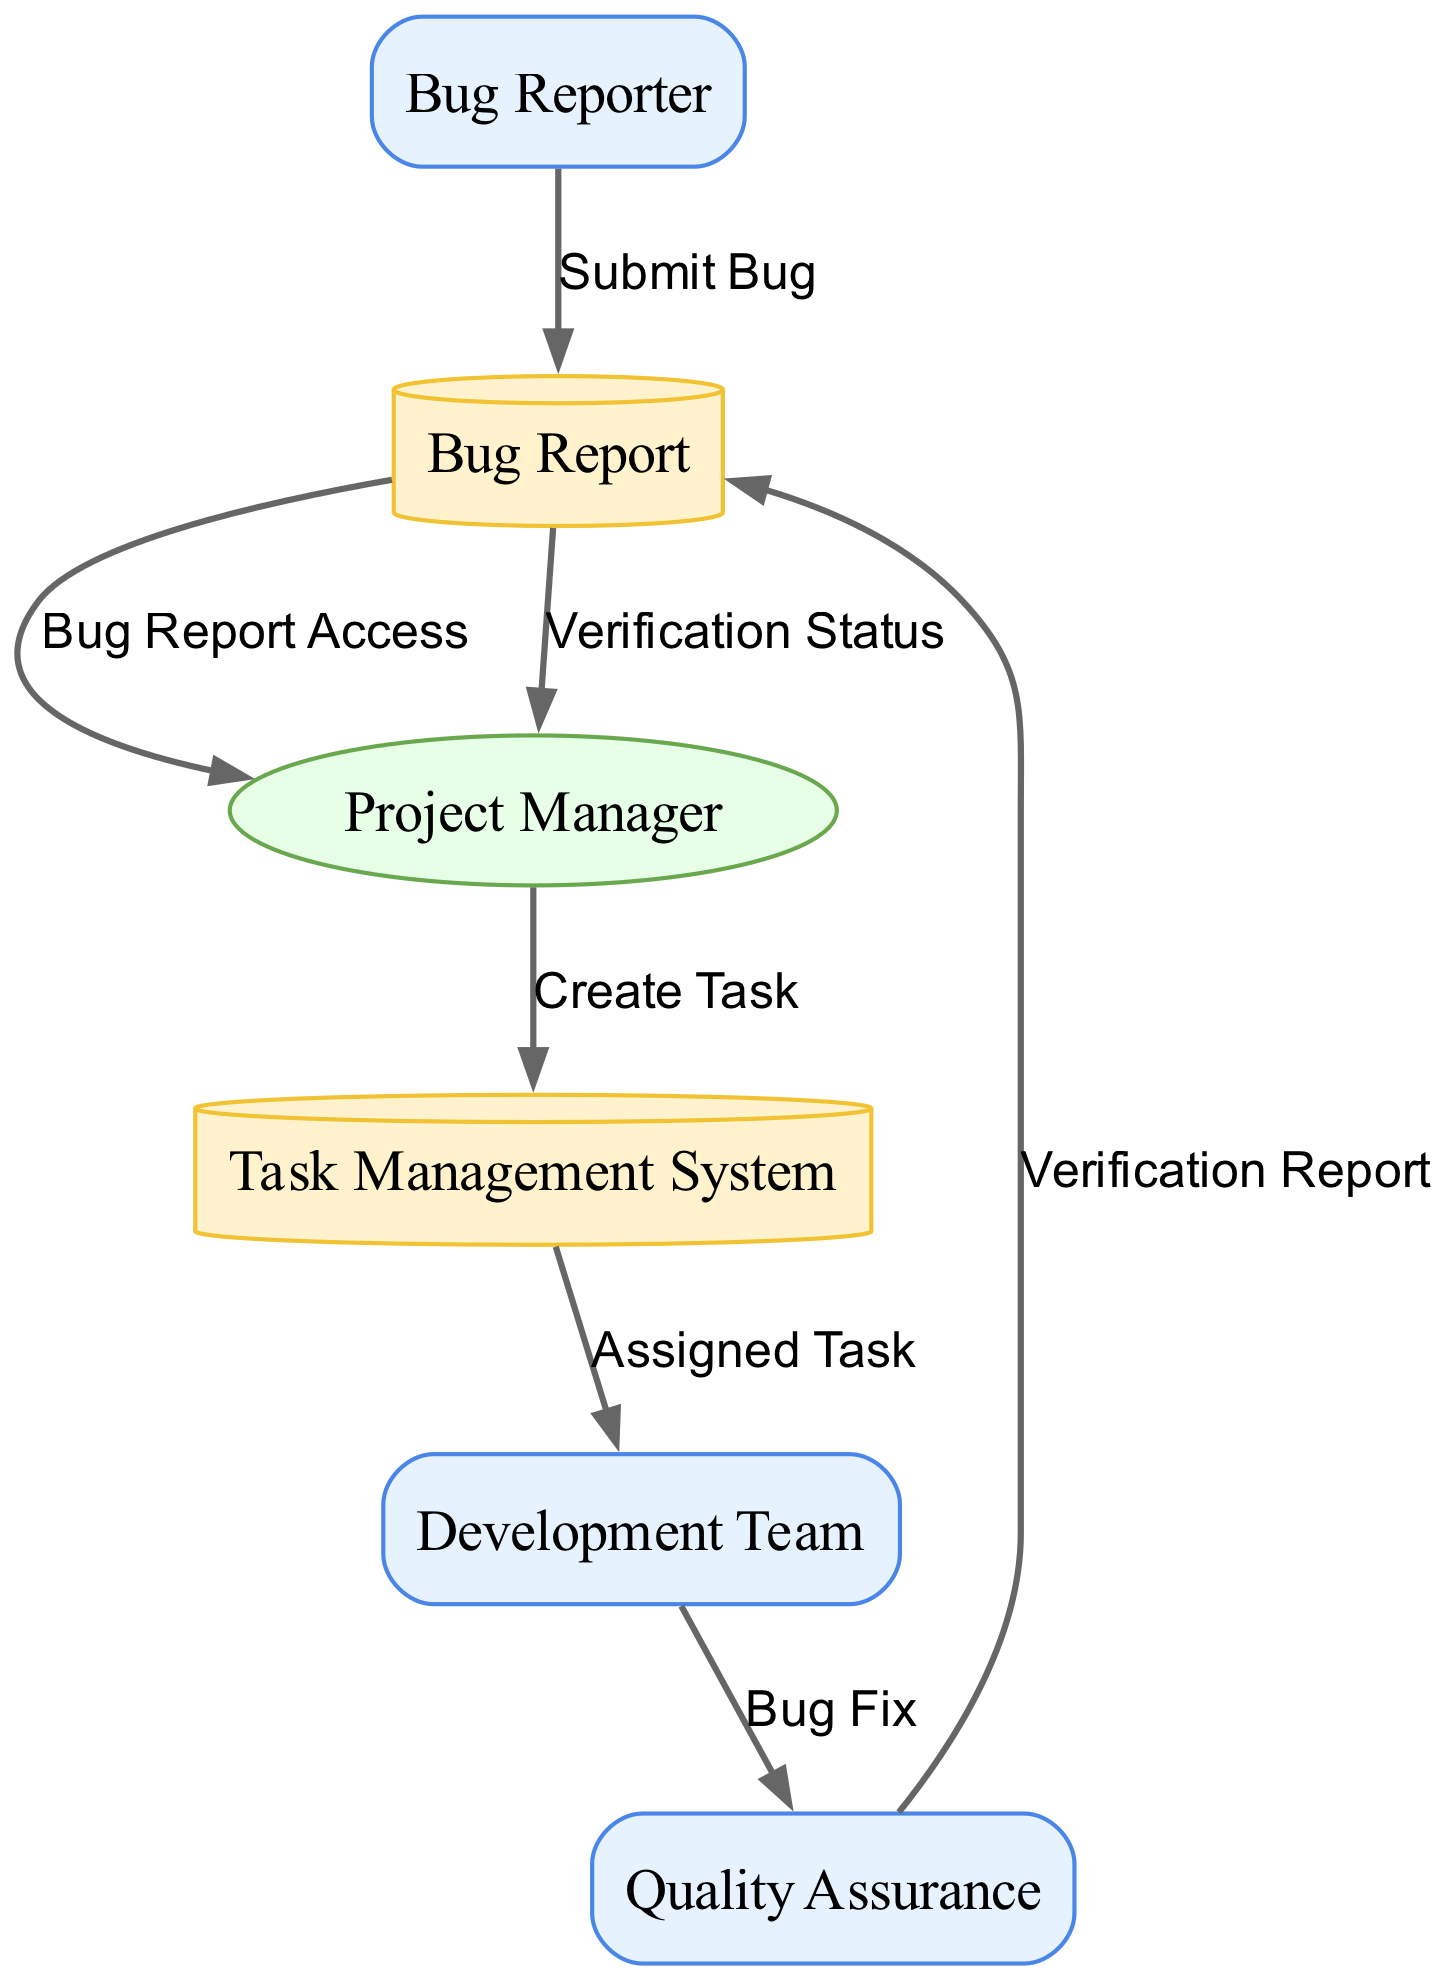What's the first external entity in the diagram? The first external entity listed is "Bug Reporter," which is noted as the individual who submits bug reports.
Answer: Bug Reporter How many data stores are represented in the diagram? The diagram contains two data stores: "Bug Report" and "Task Management System," as identified by the shapes representing data storage.
Answer: 2 What is the process conducted by the Project Manager? The Project Manager's process involves reviewing and prioritizing submitted bug reports, as described in its definition.
Answer: Review and prioritize Which external entity is responsible for fixing bugs? The "Development Team" is the external entity responsible for fixing bugs, as indicated in the diagram.
Answer: Development Team What flow follows the "Verification Report"? After the "Verification Report" is created, the next flow is to "Bug Report," where the quality assurance updates the bug report repository.
Answer: Bug Report What is the last step of the critical path in this workflow? The last step of the critical path is that the Project Manager receives the "Verification Status" from the bug report repository, completing the workflow.
Answer: Verification Status How does the "Bug Report" data store relate to the "Project Manager"? The "Bug Report" data store allows the Project Manager to access bug reports for review and prioritization, establishing a direct flow between them.
Answer: Bug Report Access What task does the Project Manager create in the Task Management System? The Project Manager creates a task in the Task Management System based on the bug report received, which is an action that initiates the fixing process.
Answer: Create Task What is the data communicated from the Development Team to Quality Assurance? The data communicated is the "Bug Fix," indicating that the Development Team has corrected the reported issue and is notifying the Quality Assurance team for verification.
Answer: Bug Fix 